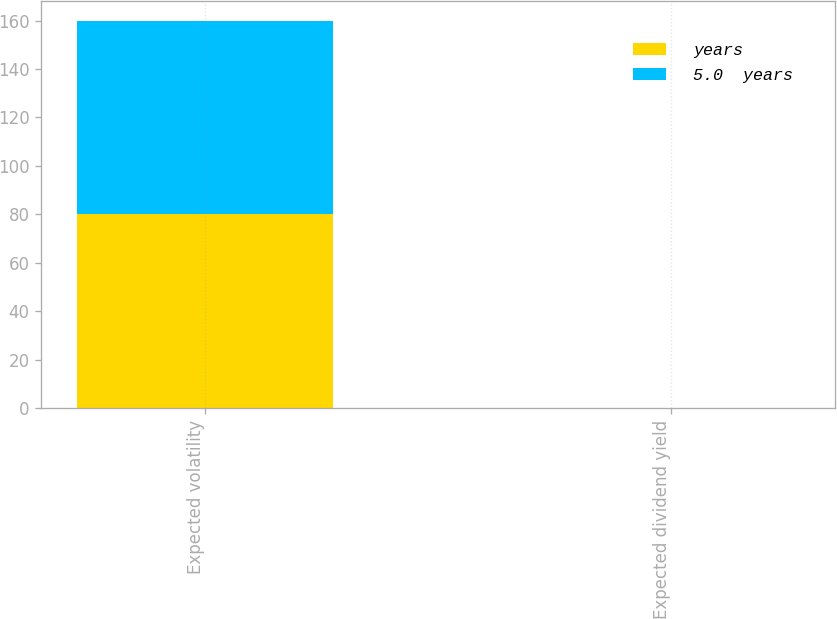<chart> <loc_0><loc_0><loc_500><loc_500><stacked_bar_chart><ecel><fcel>Expected volatility<fcel>Expected dividend yield<nl><fcel>years<fcel>80<fcel>0<nl><fcel>5.0  years<fcel>80<fcel>0<nl></chart> 